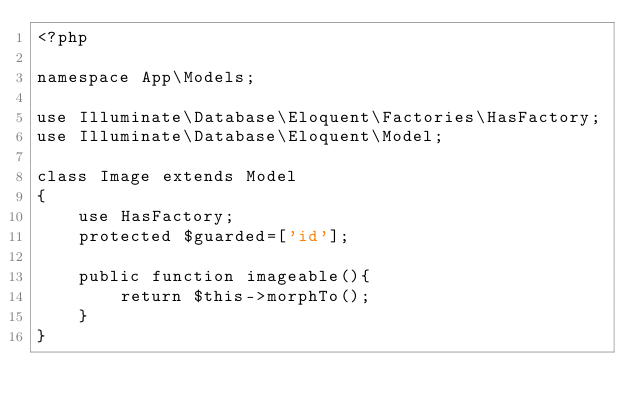Convert code to text. <code><loc_0><loc_0><loc_500><loc_500><_PHP_><?php

namespace App\Models;

use Illuminate\Database\Eloquent\Factories\HasFactory;
use Illuminate\Database\Eloquent\Model;

class Image extends Model
{
    use HasFactory;
    protected $guarded=['id'];

    public function imageable(){
        return $this->morphTo();
    }
}
</code> 